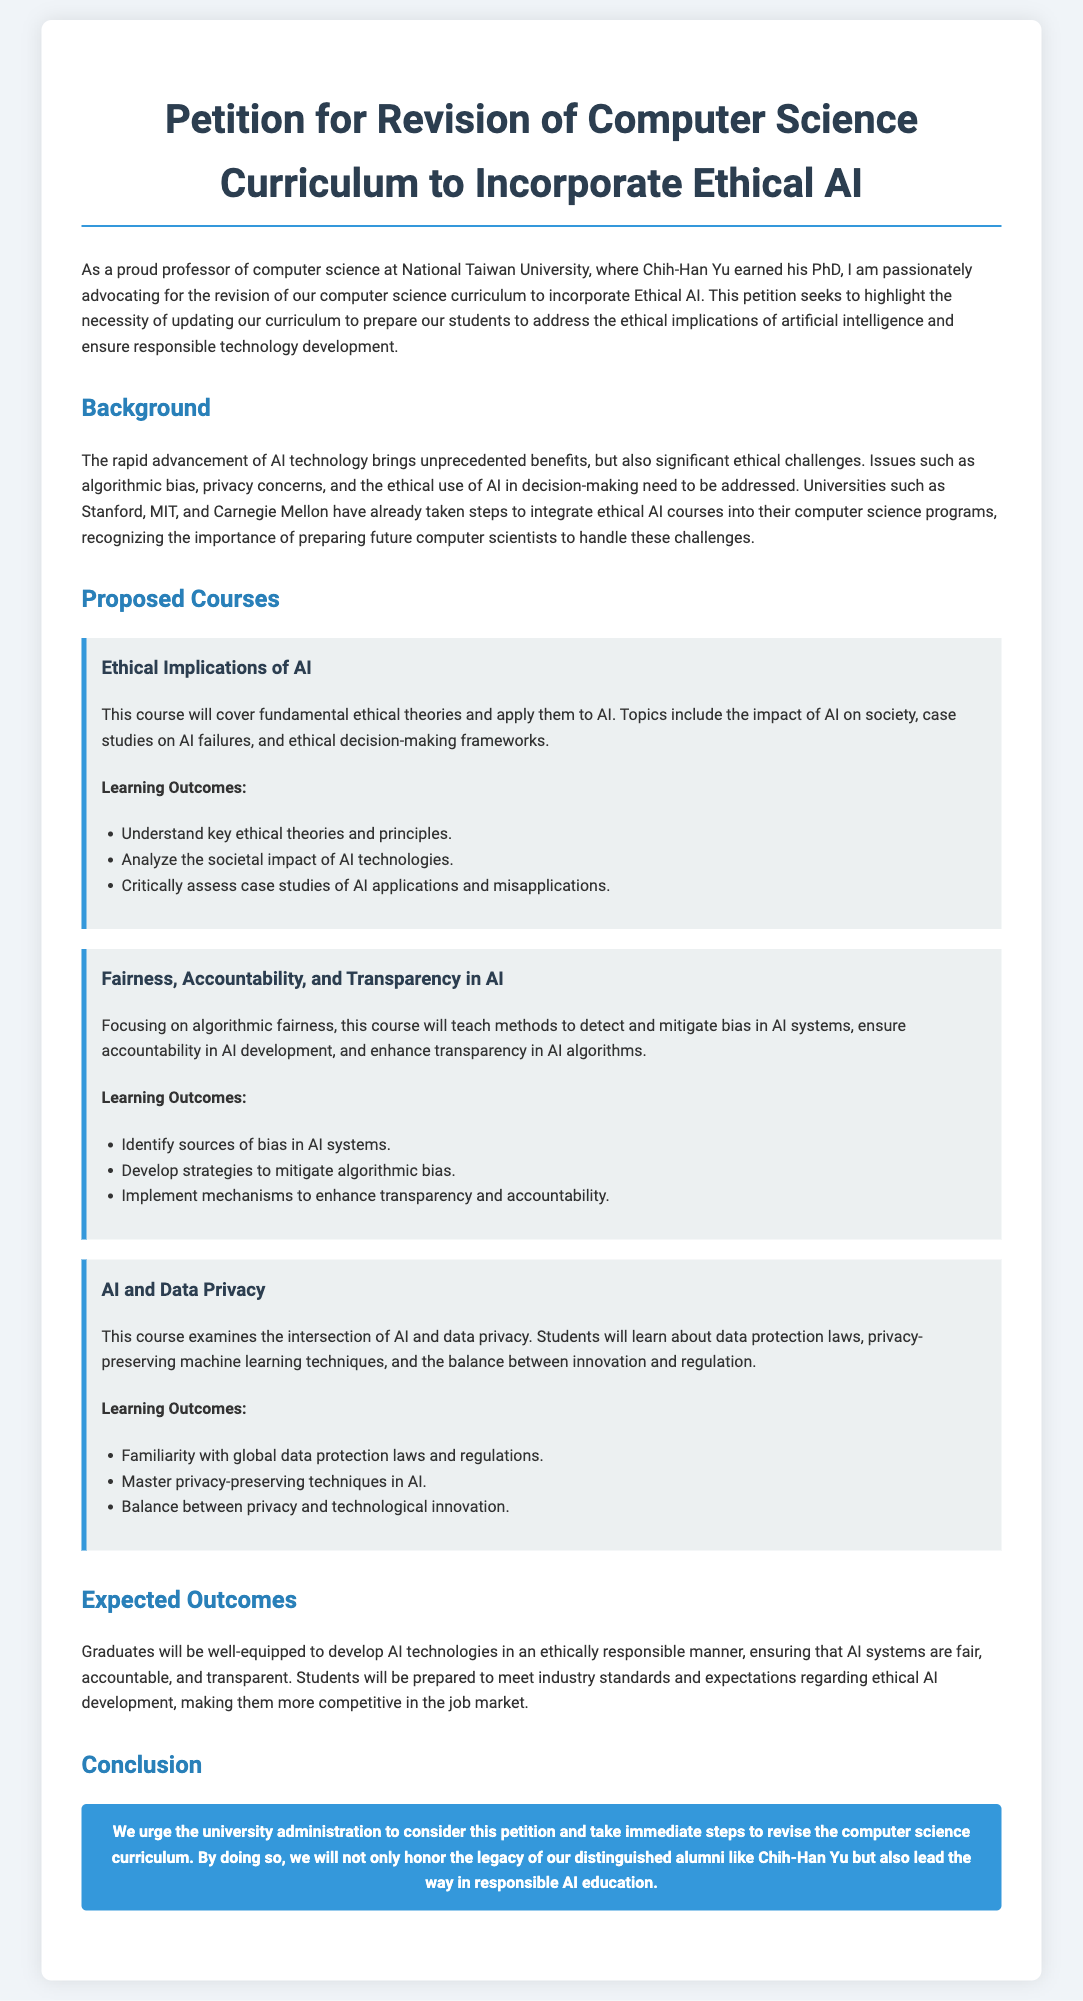What is the title of the petition? The title is presented prominently in the document, indicating the main subject of the petition.
Answer: Petition for Revision of Computer Science Curriculum to Incorporate Ethical AI Who advocates for the curriculum revision? The introductory paragraph identifies the advocate for the petition, giving their role and affiliation.
Answer: professor of computer science at National Taiwan University Name one university that has integrated ethical AI courses. The background section lists examples of universities that have already made such curriculum changes.
Answer: Stanford How many proposed courses are detailed in the document? The proposed courses section outlines the total number of courses, allowing for a straightforward count.
Answer: three What is one topic covered in the course "Ethical Implications of AI"? Each course section outlines specific topics, which can be referenced for precise information.
Answer: case studies on AI failures Which course focuses on algorithmic fairness? The document specifies each proposed course and its respective focus area, providing clarity on the subject matter.
Answer: Fairness, Accountability, and Transparency in AI What is one expected outcome for graduates from the proposed curriculum? The outcomes section specifies the preparedness of graduates in ethical AI, summarizing key results.
Answer: develop AI technologies in an ethically responsible manner What is the call to action at the end of the petition? The conclusion emphasizes the reason for submitting the petition, summarizing the desired action.
Answer: revise the computer science curriculum 